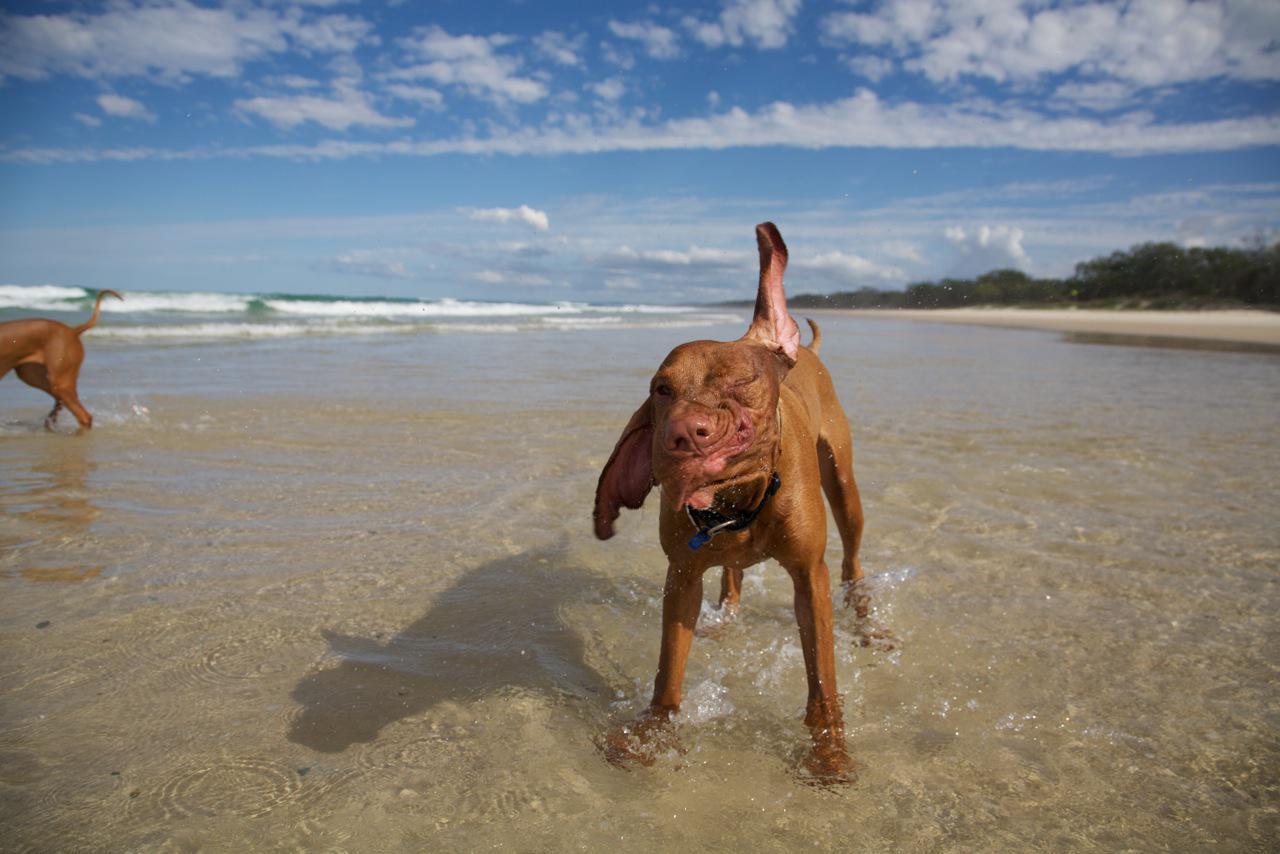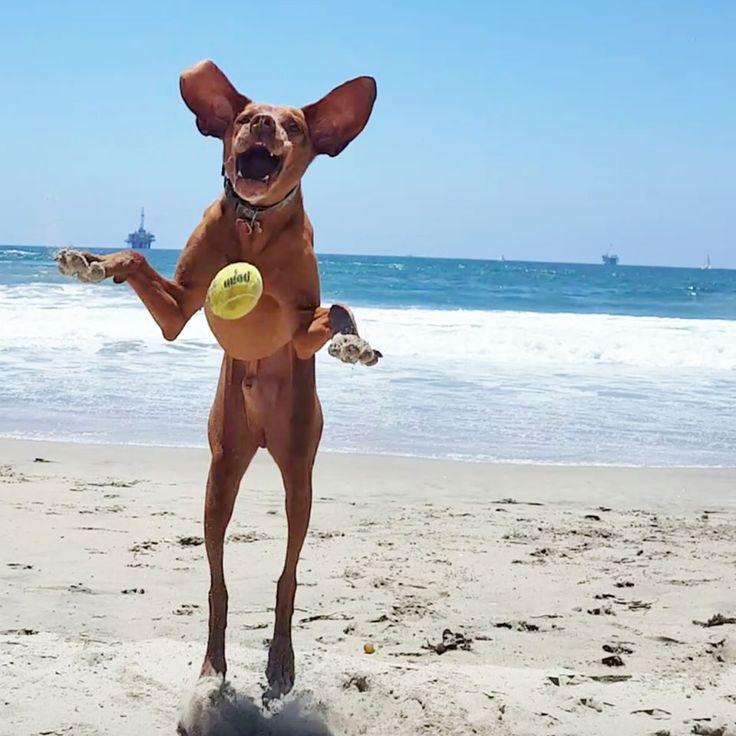The first image is the image on the left, the second image is the image on the right. Evaluate the accuracy of this statement regarding the images: "Left and right images show an orange dog at the beach, and at least one image shows a dog that is not in the water.". Is it true? Answer yes or no. Yes. The first image is the image on the left, the second image is the image on the right. Evaluate the accuracy of this statement regarding the images: "There are at least three dogs in total.". Is it true? Answer yes or no. Yes. 